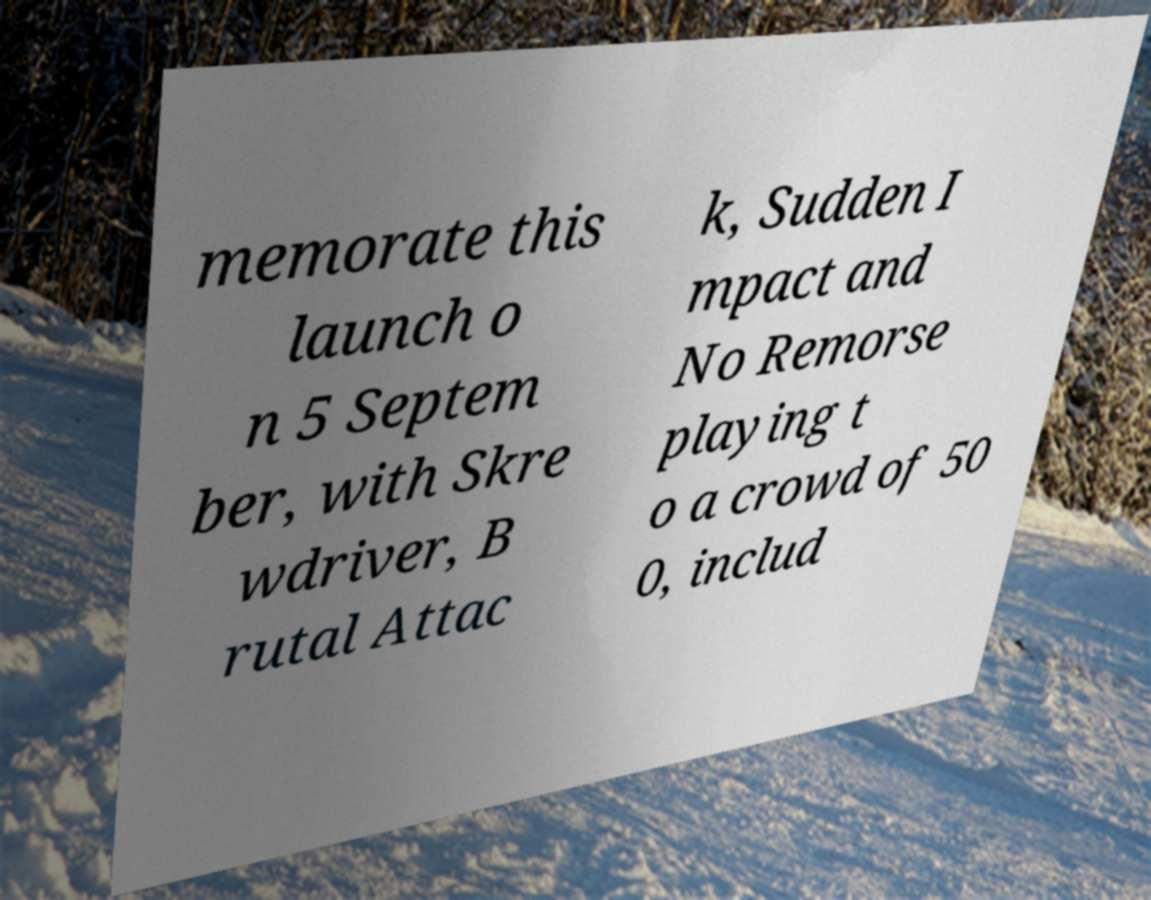Please read and relay the text visible in this image. What does it say? memorate this launch o n 5 Septem ber, with Skre wdriver, B rutal Attac k, Sudden I mpact and No Remorse playing t o a crowd of 50 0, includ 